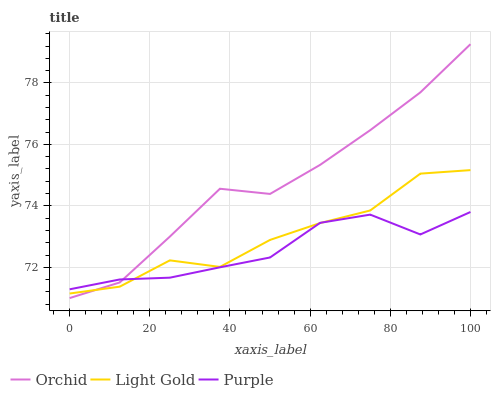Does Purple have the minimum area under the curve?
Answer yes or no. Yes. Does Orchid have the maximum area under the curve?
Answer yes or no. Yes. Does Light Gold have the minimum area under the curve?
Answer yes or no. No. Does Light Gold have the maximum area under the curve?
Answer yes or no. No. Is Orchid the smoothest?
Answer yes or no. Yes. Is Light Gold the roughest?
Answer yes or no. Yes. Is Light Gold the smoothest?
Answer yes or no. No. Is Orchid the roughest?
Answer yes or no. No. Does Orchid have the lowest value?
Answer yes or no. Yes. Does Light Gold have the lowest value?
Answer yes or no. No. Does Orchid have the highest value?
Answer yes or no. Yes. Does Light Gold have the highest value?
Answer yes or no. No. Does Purple intersect Light Gold?
Answer yes or no. Yes. Is Purple less than Light Gold?
Answer yes or no. No. Is Purple greater than Light Gold?
Answer yes or no. No. 